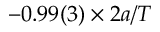<formula> <loc_0><loc_0><loc_500><loc_500>- 0 . 9 9 ( 3 ) \times 2 a / T</formula> 